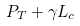Convert formula to latex. <formula><loc_0><loc_0><loc_500><loc_500>P _ { T } + \gamma L _ { c }</formula> 